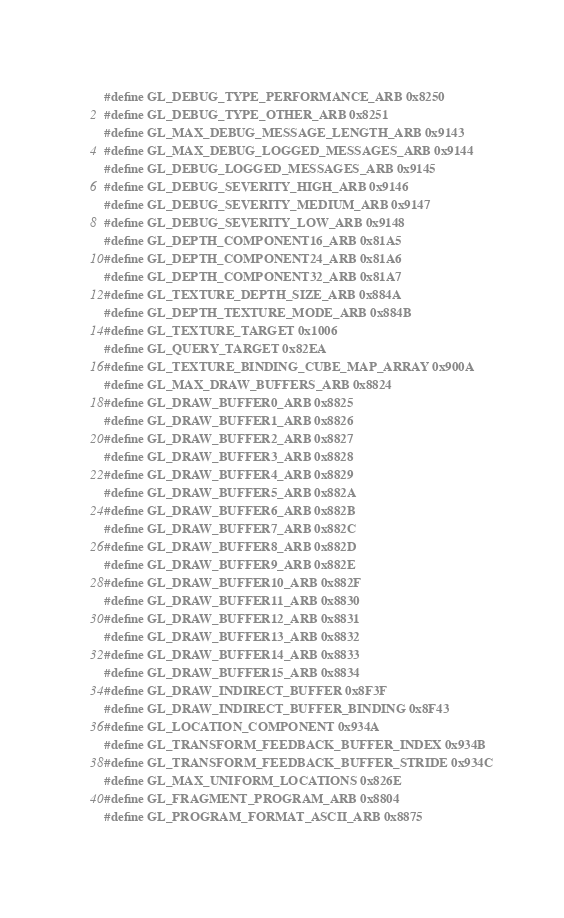Convert code to text. <code><loc_0><loc_0><loc_500><loc_500><_C_>#define GL_DEBUG_TYPE_PERFORMANCE_ARB 0x8250
#define GL_DEBUG_TYPE_OTHER_ARB 0x8251
#define GL_MAX_DEBUG_MESSAGE_LENGTH_ARB 0x9143
#define GL_MAX_DEBUG_LOGGED_MESSAGES_ARB 0x9144
#define GL_DEBUG_LOGGED_MESSAGES_ARB 0x9145
#define GL_DEBUG_SEVERITY_HIGH_ARB 0x9146
#define GL_DEBUG_SEVERITY_MEDIUM_ARB 0x9147
#define GL_DEBUG_SEVERITY_LOW_ARB 0x9148
#define GL_DEPTH_COMPONENT16_ARB 0x81A5
#define GL_DEPTH_COMPONENT24_ARB 0x81A6
#define GL_DEPTH_COMPONENT32_ARB 0x81A7
#define GL_TEXTURE_DEPTH_SIZE_ARB 0x884A
#define GL_DEPTH_TEXTURE_MODE_ARB 0x884B
#define GL_TEXTURE_TARGET 0x1006
#define GL_QUERY_TARGET 0x82EA
#define GL_TEXTURE_BINDING_CUBE_MAP_ARRAY 0x900A
#define GL_MAX_DRAW_BUFFERS_ARB 0x8824
#define GL_DRAW_BUFFER0_ARB 0x8825
#define GL_DRAW_BUFFER1_ARB 0x8826
#define GL_DRAW_BUFFER2_ARB 0x8827
#define GL_DRAW_BUFFER3_ARB 0x8828
#define GL_DRAW_BUFFER4_ARB 0x8829
#define GL_DRAW_BUFFER5_ARB 0x882A
#define GL_DRAW_BUFFER6_ARB 0x882B
#define GL_DRAW_BUFFER7_ARB 0x882C
#define GL_DRAW_BUFFER8_ARB 0x882D
#define GL_DRAW_BUFFER9_ARB 0x882E
#define GL_DRAW_BUFFER10_ARB 0x882F
#define GL_DRAW_BUFFER11_ARB 0x8830
#define GL_DRAW_BUFFER12_ARB 0x8831
#define GL_DRAW_BUFFER13_ARB 0x8832
#define GL_DRAW_BUFFER14_ARB 0x8833
#define GL_DRAW_BUFFER15_ARB 0x8834
#define GL_DRAW_INDIRECT_BUFFER 0x8F3F
#define GL_DRAW_INDIRECT_BUFFER_BINDING 0x8F43
#define GL_LOCATION_COMPONENT 0x934A
#define GL_TRANSFORM_FEEDBACK_BUFFER_INDEX 0x934B
#define GL_TRANSFORM_FEEDBACK_BUFFER_STRIDE 0x934C
#define GL_MAX_UNIFORM_LOCATIONS 0x826E
#define GL_FRAGMENT_PROGRAM_ARB 0x8804
#define GL_PROGRAM_FORMAT_ASCII_ARB 0x8875</code> 